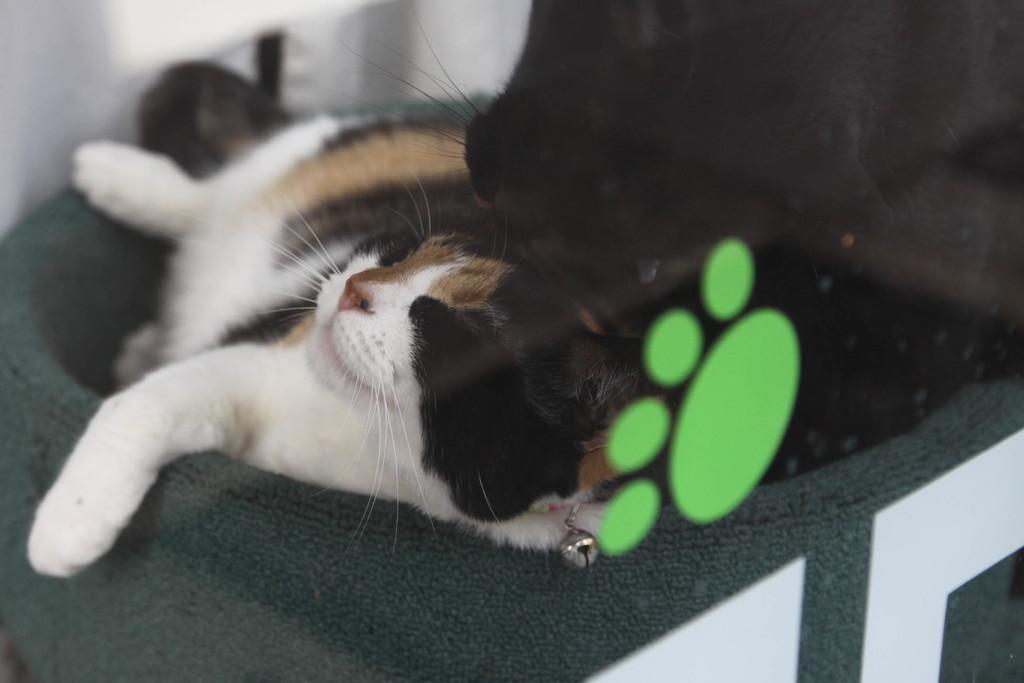In one or two sentences, can you explain what this image depicts? In this image there are two cats. In the foreground of the image there is a glass on which there is a green color footprint. 